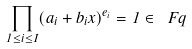Convert formula to latex. <formula><loc_0><loc_0><loc_500><loc_500>\prod _ { 1 \leq i \leq I } ( a _ { i } + b _ { i } x ) ^ { e _ { i } } = 1 \in \ F q</formula> 